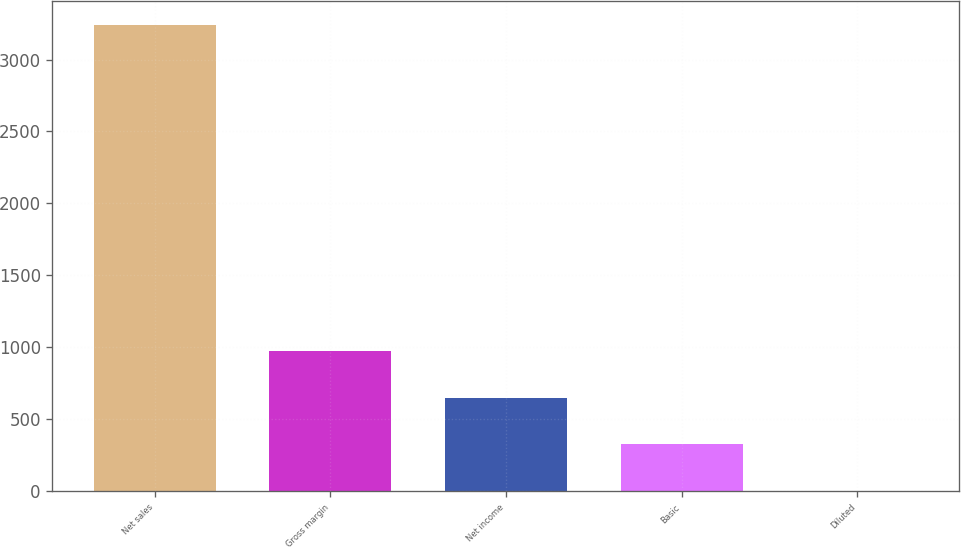<chart> <loc_0><loc_0><loc_500><loc_500><bar_chart><fcel>Net sales<fcel>Gross margin<fcel>Net income<fcel>Basic<fcel>Diluted<nl><fcel>3243<fcel>973.15<fcel>648.88<fcel>324.61<fcel>0.34<nl></chart> 